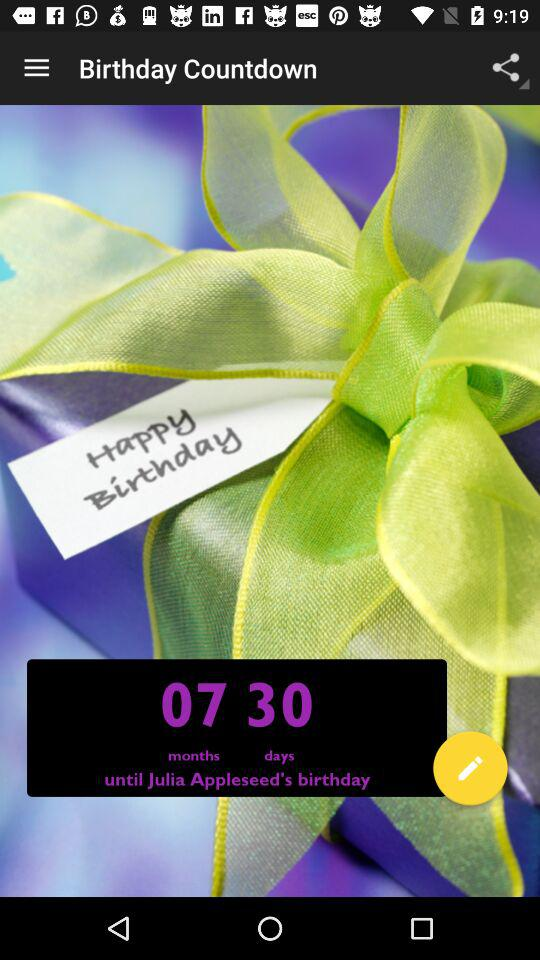How many months and days are left in the birthday countdown? There are 7 months and 30 days left in the birthday countdown. 